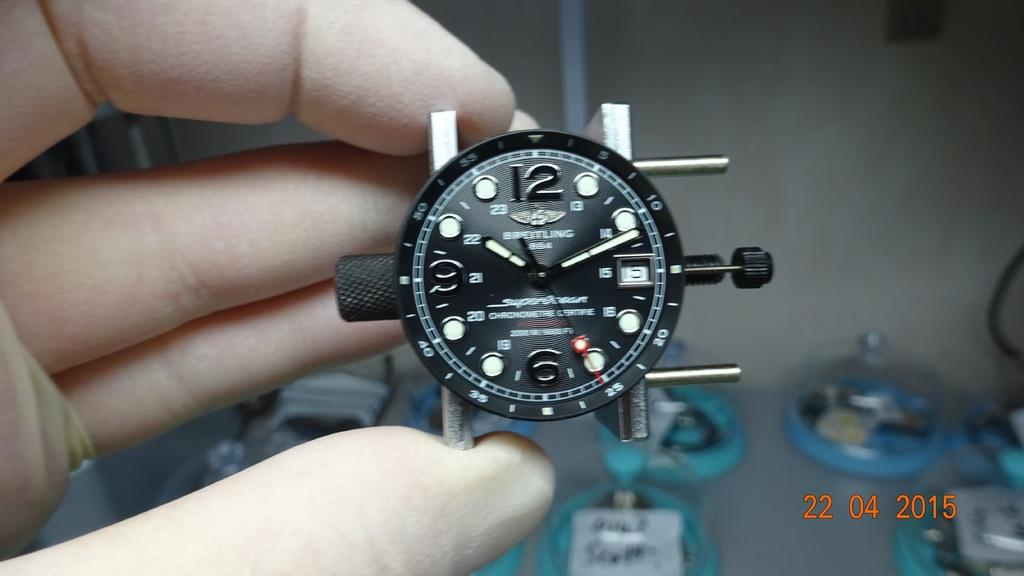<image>
Describe the image concisely. Person holding a watch with the hands on the numbers 10 and 2. 